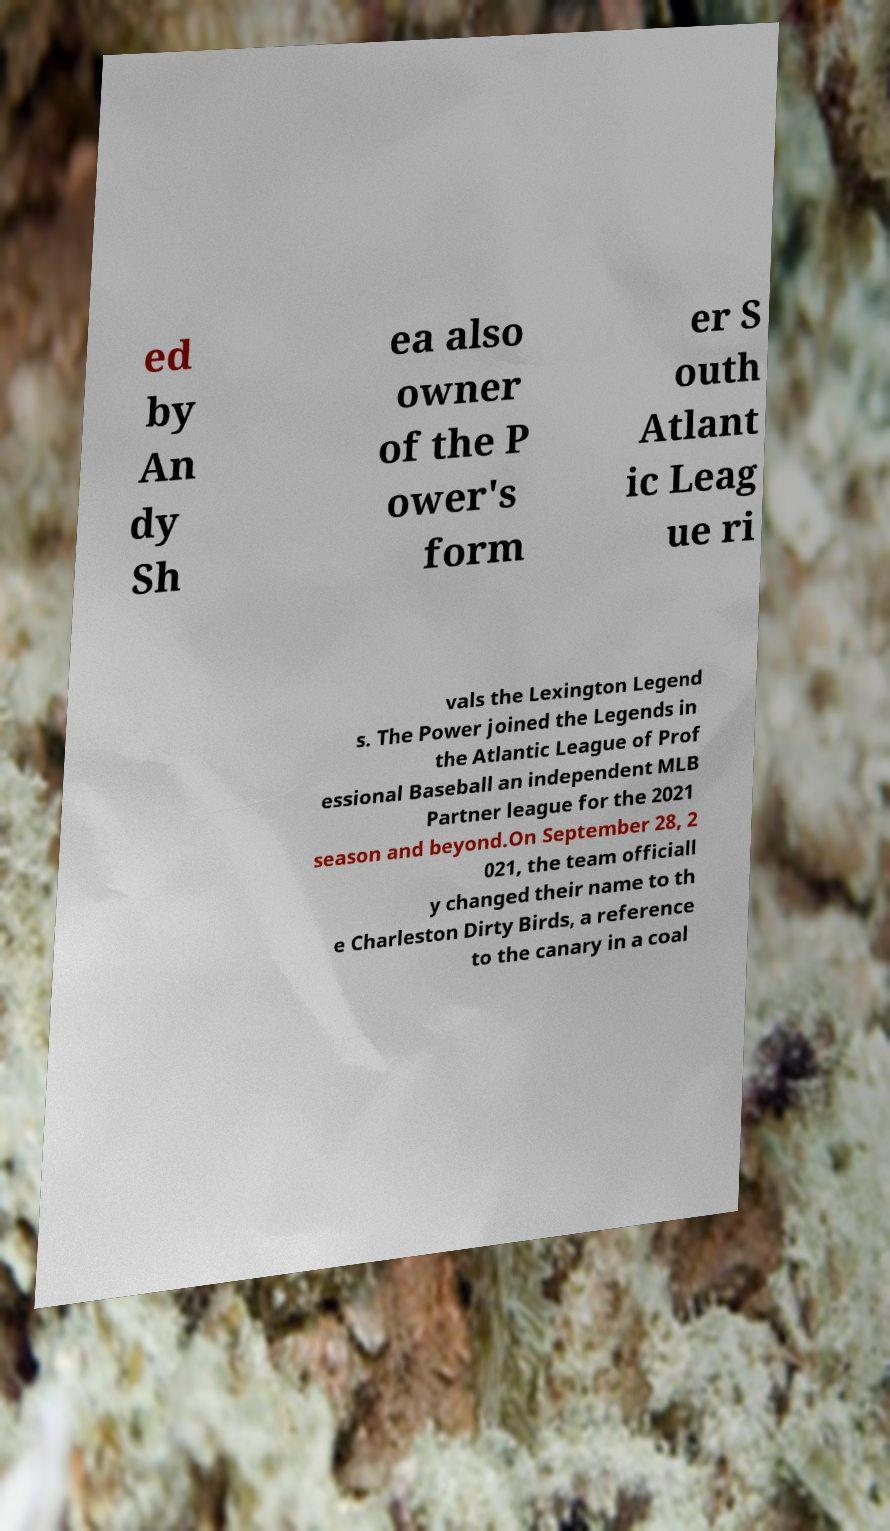Please read and relay the text visible in this image. What does it say? ed by An dy Sh ea also owner of the P ower's form er S outh Atlant ic Leag ue ri vals the Lexington Legend s. The Power joined the Legends in the Atlantic League of Prof essional Baseball an independent MLB Partner league for the 2021 season and beyond.On September 28, 2 021, the team officiall y changed their name to th e Charleston Dirty Birds, a reference to the canary in a coal 